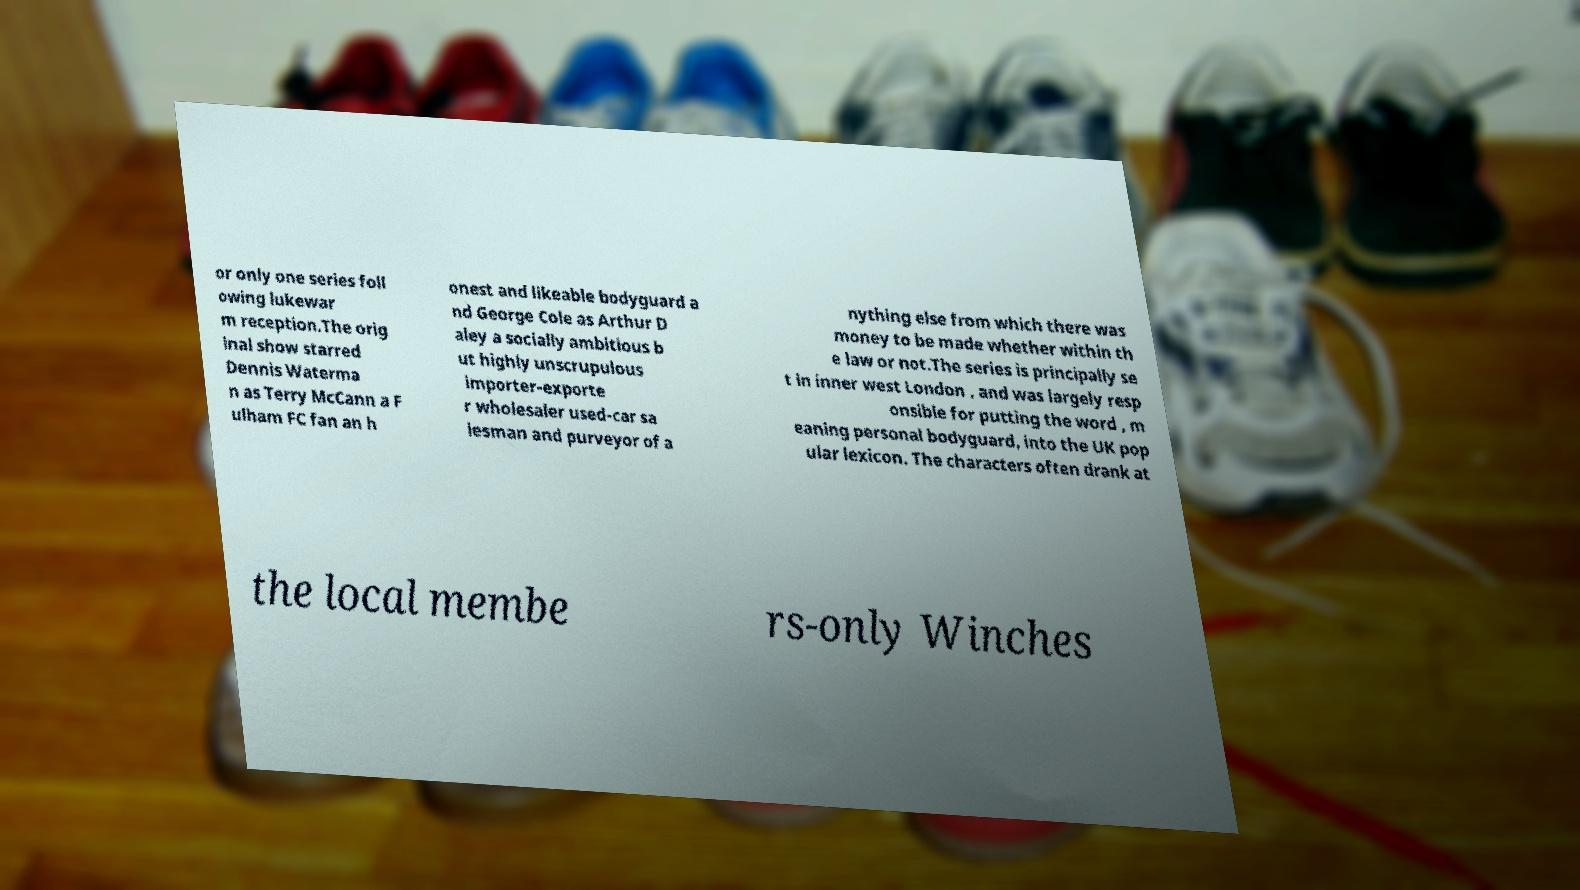Could you extract and type out the text from this image? or only one series foll owing lukewar m reception.The orig inal show starred Dennis Waterma n as Terry McCann a F ulham FC fan an h onest and likeable bodyguard a nd George Cole as Arthur D aley a socially ambitious b ut highly unscrupulous importer-exporte r wholesaler used-car sa lesman and purveyor of a nything else from which there was money to be made whether within th e law or not.The series is principally se t in inner west London , and was largely resp onsible for putting the word , m eaning personal bodyguard, into the UK pop ular lexicon. The characters often drank at the local membe rs-only Winches 